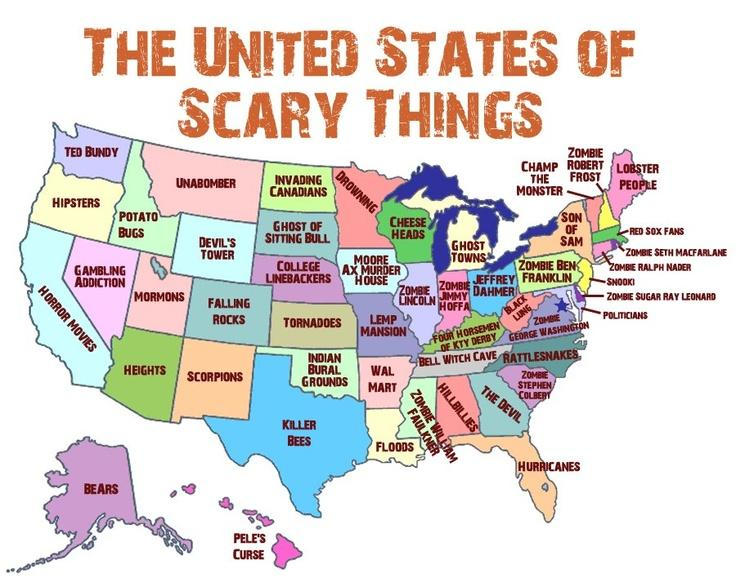Specify some key components in this picture. The region located to the south of the Heights is home to bears. The island of Pele's Curse lies to the south of Killer Bees, as declared. The region located to the north of Wal-Mart is Lemp Mansion. 